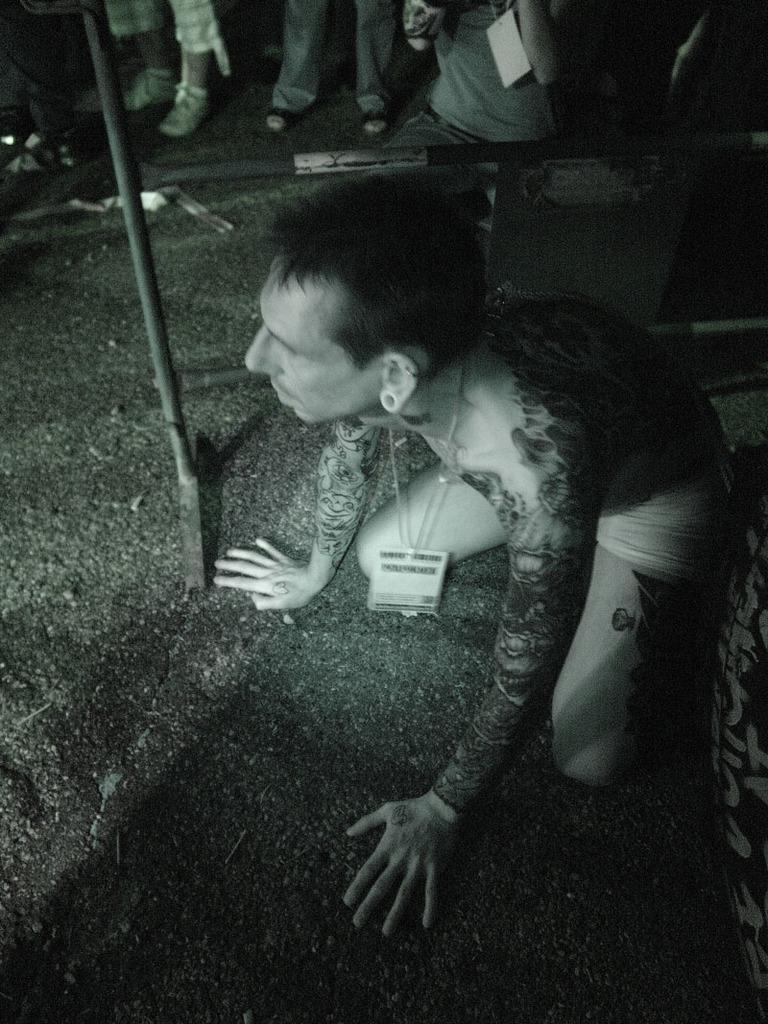Describe this image in one or two sentences. In this image there is a person in a squat position, and at the background there are iron rods, group of persons. 